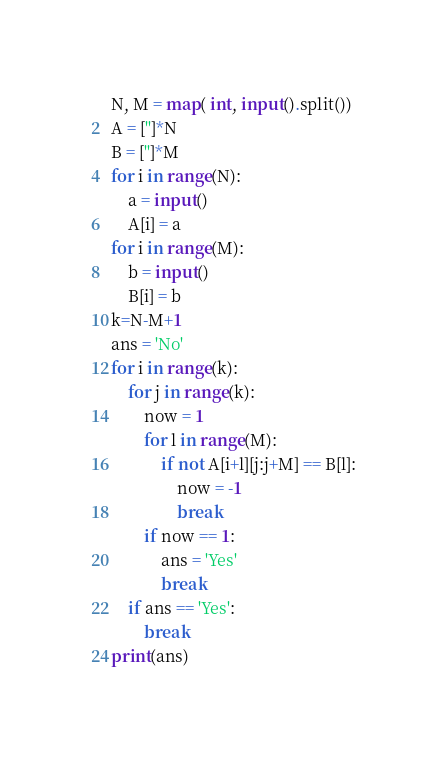Convert code to text. <code><loc_0><loc_0><loc_500><loc_500><_Python_>N, M = map( int, input().split())
A = ['']*N
B = ['']*M
for i in range(N):
    a = input()
    A[i] = a
for i in range(M):
    b = input()
    B[i] = b
k=N-M+1
ans = 'No'
for i in range(k):
    for j in range(k):
        now = 1
        for l in range(M):
            if not A[i+l][j:j+M] == B[l]:
                now = -1
                break
        if now == 1:
            ans = 'Yes'
            break
    if ans == 'Yes':
        break
print(ans)</code> 